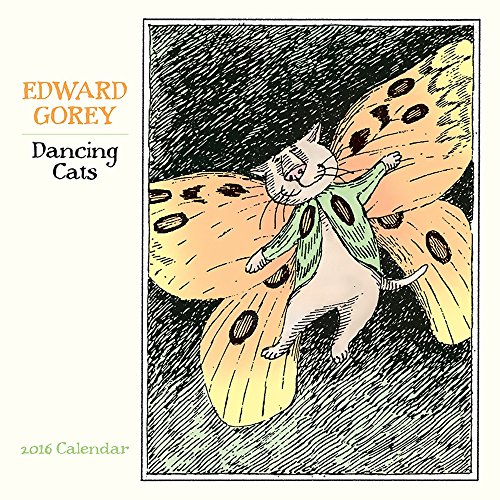Which year's calendar is this? This artistic calendar captures the essence of 2016 through quirky illustrations that any Edward Gorey fan would be proud to display. 